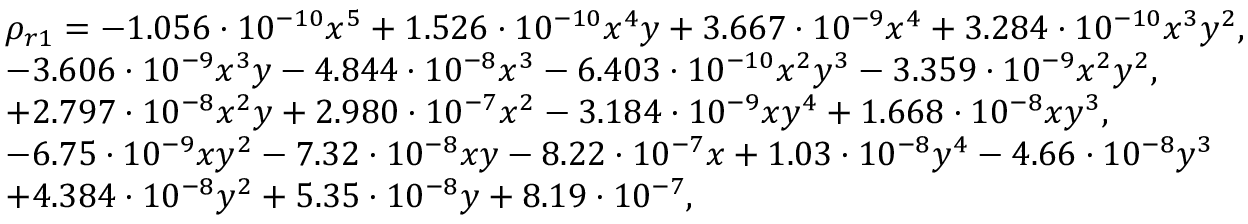Convert formula to latex. <formula><loc_0><loc_0><loc_500><loc_500>\begin{array} { r l } & { \rho _ { r 1 } = - 1 . 0 5 6 \cdot 1 0 ^ { - 1 0 } x ^ { 5 } + 1 . 5 2 6 \cdot 1 0 ^ { - 1 0 } x ^ { 4 } y + 3 . 6 6 7 \cdot 1 0 ^ { - 9 } x ^ { 4 } + 3 . 2 8 4 \cdot 1 0 ^ { - 1 0 } x ^ { 3 } y ^ { 2 } , } \\ & { - 3 . 6 0 6 \cdot 1 0 ^ { - 9 } x ^ { 3 } y - 4 . 8 4 4 \cdot 1 0 ^ { - 8 } x ^ { 3 } - 6 . 4 0 3 \cdot 1 0 ^ { - 1 0 } x ^ { 2 } y ^ { 3 } - 3 . 3 5 9 \cdot 1 0 ^ { - 9 } x ^ { 2 } y ^ { 2 } , } \\ & { + 2 . 7 9 7 \cdot 1 0 ^ { - 8 } x ^ { 2 } y + 2 . 9 8 0 \cdot 1 0 ^ { - 7 } x ^ { 2 } - 3 . 1 8 4 \cdot 1 0 ^ { - 9 } x y ^ { 4 } + 1 . 6 6 8 \cdot 1 0 ^ { - 8 } x y ^ { 3 } , } \\ & { - 6 . 7 5 \cdot 1 0 ^ { - 9 } x y ^ { 2 } - 7 . 3 2 \cdot 1 0 ^ { - 8 } x y - 8 . 2 2 \cdot 1 0 ^ { - 7 } x + 1 . 0 3 \cdot 1 0 ^ { - 8 } y ^ { 4 } - 4 . 6 6 \cdot 1 0 ^ { - 8 } y ^ { 3 } } \\ & { + 4 . 3 8 4 \cdot 1 0 ^ { - 8 } y ^ { 2 } + 5 . 3 5 \cdot 1 0 ^ { - 8 } y + 8 . 1 9 \cdot 1 0 ^ { - 7 } , } \end{array}</formula> 